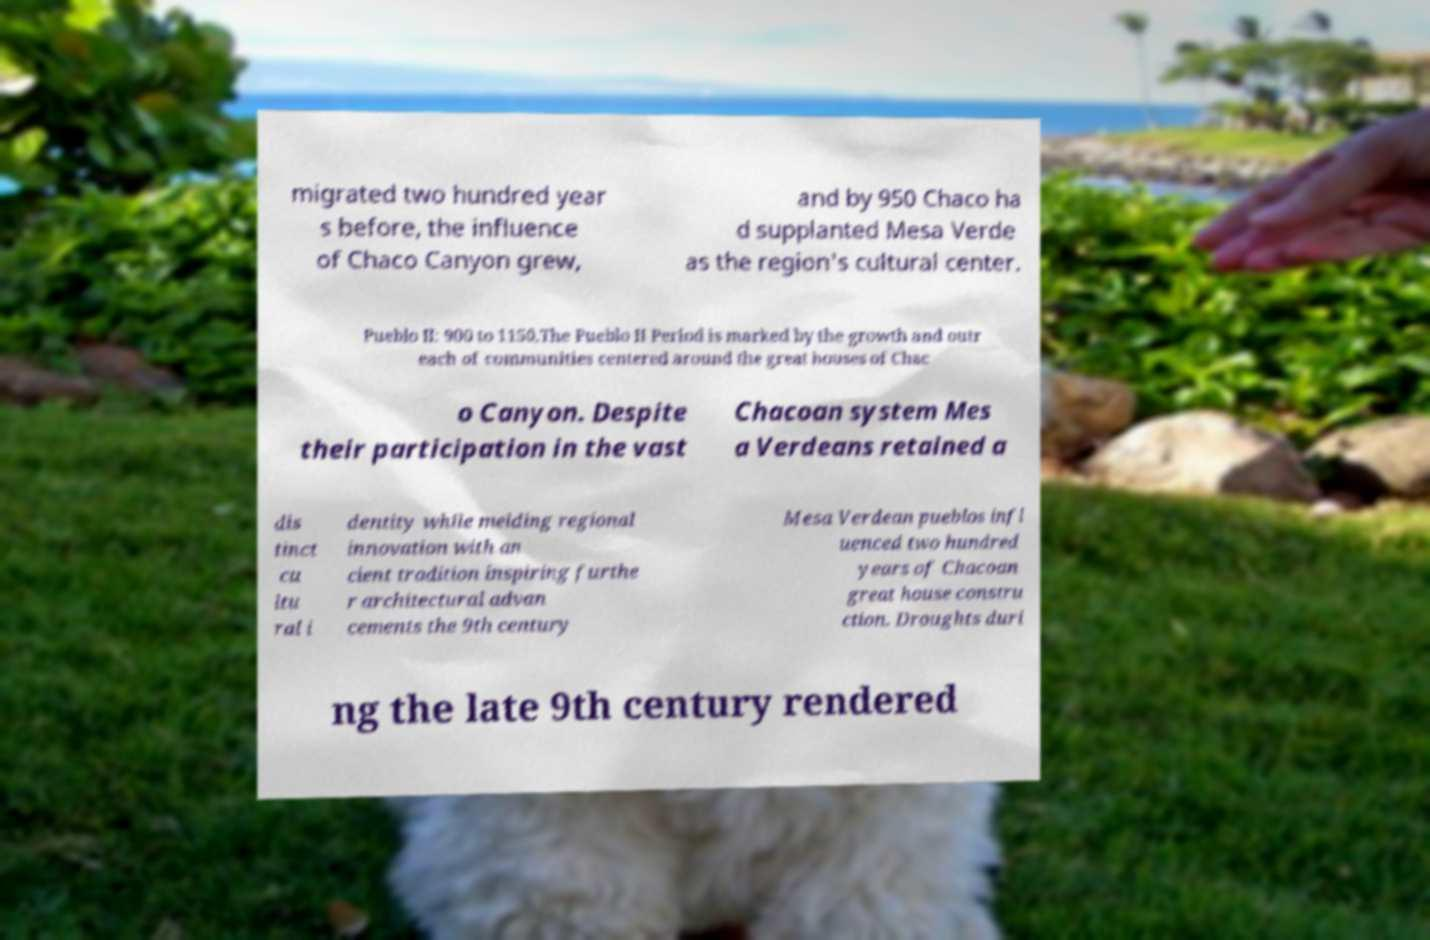What messages or text are displayed in this image? I need them in a readable, typed format. migrated two hundred year s before, the influence of Chaco Canyon grew, and by 950 Chaco ha d supplanted Mesa Verde as the region's cultural center. Pueblo II: 900 to 1150.The Pueblo II Period is marked by the growth and outr each of communities centered around the great houses of Chac o Canyon. Despite their participation in the vast Chacoan system Mes a Verdeans retained a dis tinct cu ltu ral i dentity while melding regional innovation with an cient tradition inspiring furthe r architectural advan cements the 9th century Mesa Verdean pueblos infl uenced two hundred years of Chacoan great house constru ction. Droughts duri ng the late 9th century rendered 